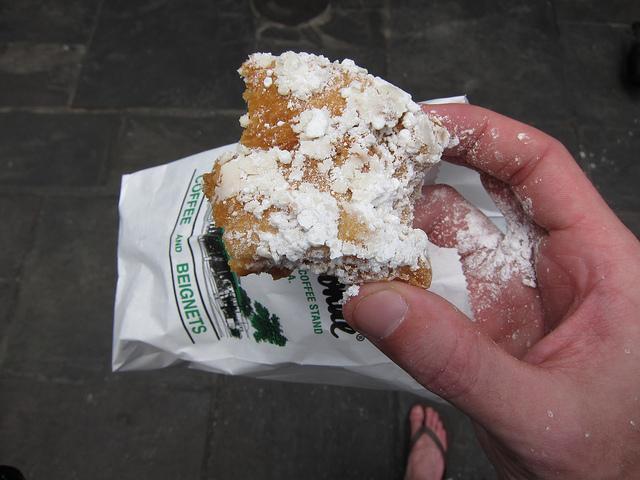How many hands are in the picture?
Give a very brief answer. 1. How many donuts can you see?
Give a very brief answer. 1. 